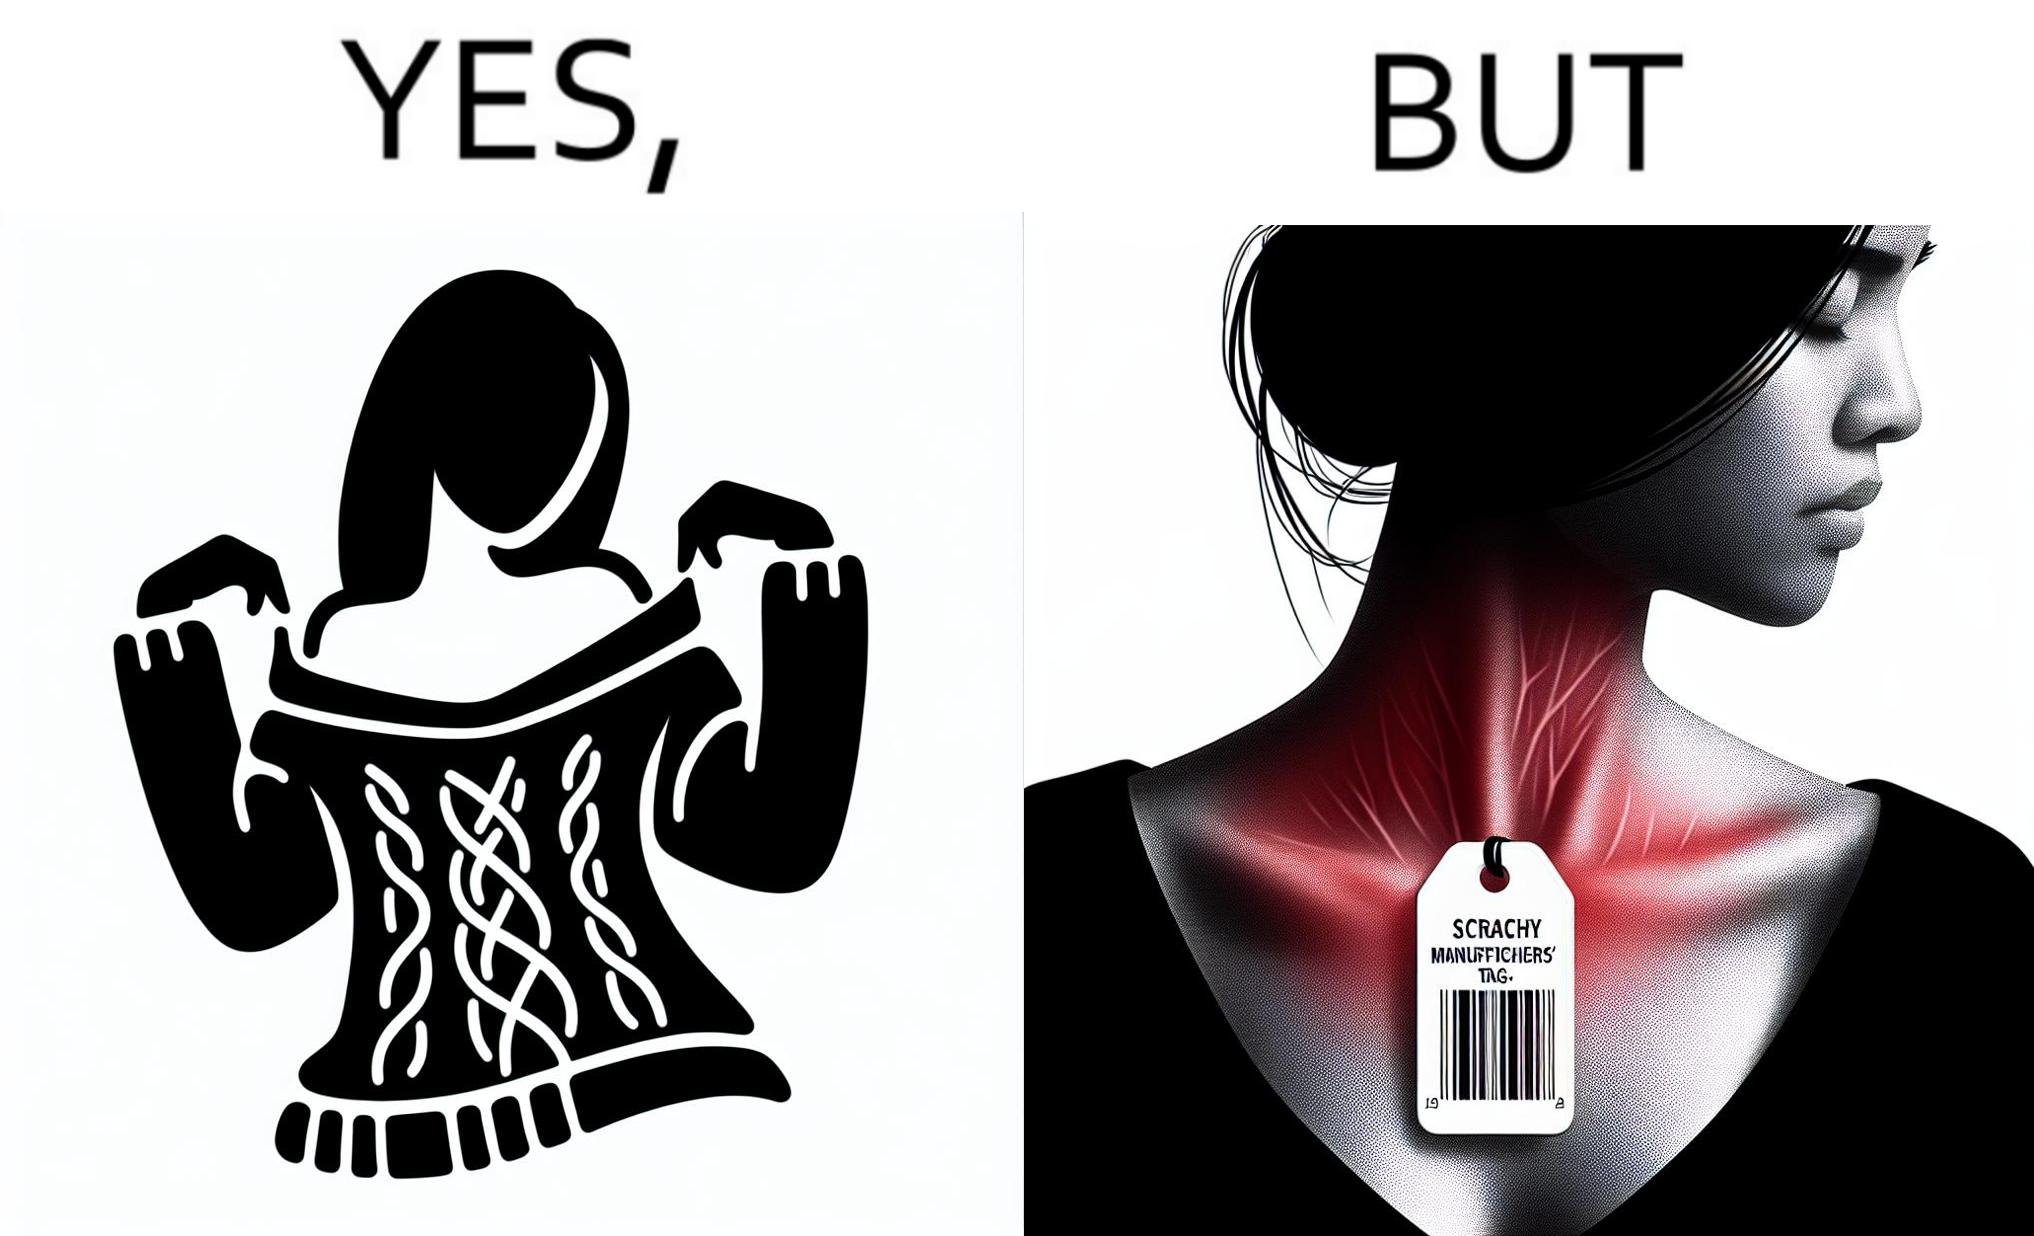Describe what you see in the left and right parts of this image. In the left part of the image: It is a woman enjoying the warmth and comfort of her sweater In the right part of the image: It a womans neck, irritated and red due to manufacturers tags on her clothes 